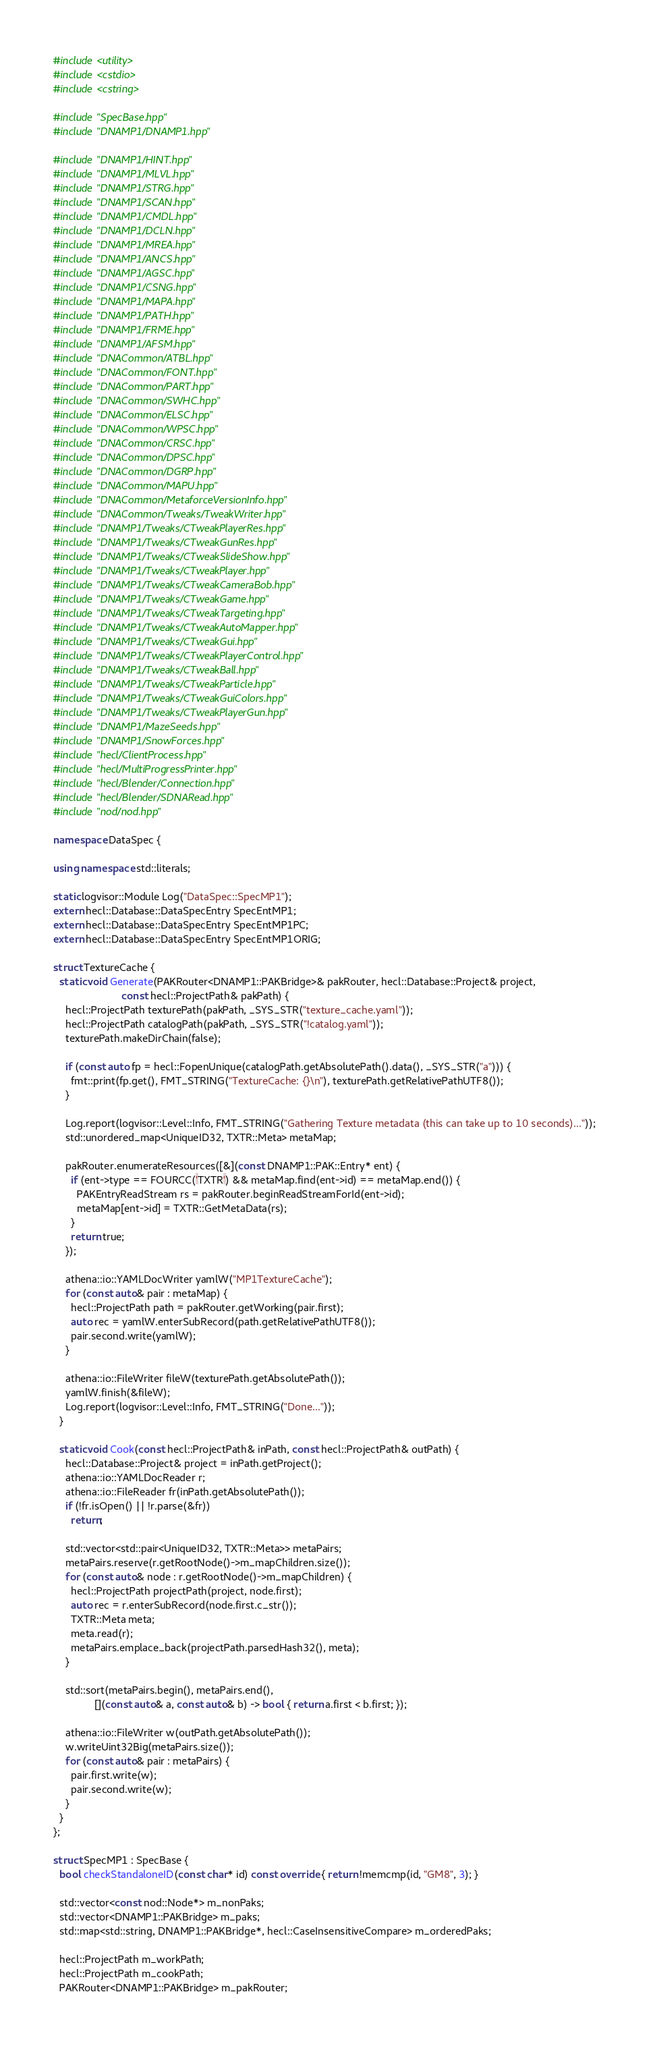Convert code to text. <code><loc_0><loc_0><loc_500><loc_500><_C++_>#include <utility>
#include <cstdio>
#include <cstring>

#include "SpecBase.hpp"
#include "DNAMP1/DNAMP1.hpp"

#include "DNAMP1/HINT.hpp"
#include "DNAMP1/MLVL.hpp"
#include "DNAMP1/STRG.hpp"
#include "DNAMP1/SCAN.hpp"
#include "DNAMP1/CMDL.hpp"
#include "DNAMP1/DCLN.hpp"
#include "DNAMP1/MREA.hpp"
#include "DNAMP1/ANCS.hpp"
#include "DNAMP1/AGSC.hpp"
#include "DNAMP1/CSNG.hpp"
#include "DNAMP1/MAPA.hpp"
#include "DNAMP1/PATH.hpp"
#include "DNAMP1/FRME.hpp"
#include "DNAMP1/AFSM.hpp"
#include "DNACommon/ATBL.hpp"
#include "DNACommon/FONT.hpp"
#include "DNACommon/PART.hpp"
#include "DNACommon/SWHC.hpp"
#include "DNACommon/ELSC.hpp"
#include "DNACommon/WPSC.hpp"
#include "DNACommon/CRSC.hpp"
#include "DNACommon/DPSC.hpp"
#include "DNACommon/DGRP.hpp"
#include "DNACommon/MAPU.hpp"
#include "DNACommon/MetaforceVersionInfo.hpp"
#include "DNACommon/Tweaks/TweakWriter.hpp"
#include "DNAMP1/Tweaks/CTweakPlayerRes.hpp"
#include "DNAMP1/Tweaks/CTweakGunRes.hpp"
#include "DNAMP1/Tweaks/CTweakSlideShow.hpp"
#include "DNAMP1/Tweaks/CTweakPlayer.hpp"
#include "DNAMP1/Tweaks/CTweakCameraBob.hpp"
#include "DNAMP1/Tweaks/CTweakGame.hpp"
#include "DNAMP1/Tweaks/CTweakTargeting.hpp"
#include "DNAMP1/Tweaks/CTweakAutoMapper.hpp"
#include "DNAMP1/Tweaks/CTweakGui.hpp"
#include "DNAMP1/Tweaks/CTweakPlayerControl.hpp"
#include "DNAMP1/Tweaks/CTweakBall.hpp"
#include "DNAMP1/Tweaks/CTweakParticle.hpp"
#include "DNAMP1/Tweaks/CTweakGuiColors.hpp"
#include "DNAMP1/Tweaks/CTweakPlayerGun.hpp"
#include "DNAMP1/MazeSeeds.hpp"
#include "DNAMP1/SnowForces.hpp"
#include "hecl/ClientProcess.hpp"
#include "hecl/MultiProgressPrinter.hpp"
#include "hecl/Blender/Connection.hpp"
#include "hecl/Blender/SDNARead.hpp"
#include "nod/nod.hpp"

namespace DataSpec {

using namespace std::literals;

static logvisor::Module Log("DataSpec::SpecMP1");
extern hecl::Database::DataSpecEntry SpecEntMP1;
extern hecl::Database::DataSpecEntry SpecEntMP1PC;
extern hecl::Database::DataSpecEntry SpecEntMP1ORIG;

struct TextureCache {
  static void Generate(PAKRouter<DNAMP1::PAKBridge>& pakRouter, hecl::Database::Project& project,
                       const hecl::ProjectPath& pakPath) {
    hecl::ProjectPath texturePath(pakPath, _SYS_STR("texture_cache.yaml"));
    hecl::ProjectPath catalogPath(pakPath, _SYS_STR("!catalog.yaml"));
    texturePath.makeDirChain(false);

    if (const auto fp = hecl::FopenUnique(catalogPath.getAbsolutePath().data(), _SYS_STR("a"))) {
      fmt::print(fp.get(), FMT_STRING("TextureCache: {}\n"), texturePath.getRelativePathUTF8());
    }

    Log.report(logvisor::Level::Info, FMT_STRING("Gathering Texture metadata (this can take up to 10 seconds)..."));
    std::unordered_map<UniqueID32, TXTR::Meta> metaMap;

    pakRouter.enumerateResources([&](const DNAMP1::PAK::Entry* ent) {
      if (ent->type == FOURCC('TXTR') && metaMap.find(ent->id) == metaMap.end()) {
        PAKEntryReadStream rs = pakRouter.beginReadStreamForId(ent->id);
        metaMap[ent->id] = TXTR::GetMetaData(rs);
      }
      return true;
    });

    athena::io::YAMLDocWriter yamlW("MP1TextureCache");
    for (const auto& pair : metaMap) {
      hecl::ProjectPath path = pakRouter.getWorking(pair.first);
      auto rec = yamlW.enterSubRecord(path.getRelativePathUTF8());
      pair.second.write(yamlW);
    }

    athena::io::FileWriter fileW(texturePath.getAbsolutePath());
    yamlW.finish(&fileW);
    Log.report(logvisor::Level::Info, FMT_STRING("Done..."));
  }

  static void Cook(const hecl::ProjectPath& inPath, const hecl::ProjectPath& outPath) {
    hecl::Database::Project& project = inPath.getProject();
    athena::io::YAMLDocReader r;
    athena::io::FileReader fr(inPath.getAbsolutePath());
    if (!fr.isOpen() || !r.parse(&fr))
      return;

    std::vector<std::pair<UniqueID32, TXTR::Meta>> metaPairs;
    metaPairs.reserve(r.getRootNode()->m_mapChildren.size());
    for (const auto& node : r.getRootNode()->m_mapChildren) {
      hecl::ProjectPath projectPath(project, node.first);
      auto rec = r.enterSubRecord(node.first.c_str());
      TXTR::Meta meta;
      meta.read(r);
      metaPairs.emplace_back(projectPath.parsedHash32(), meta);
    }

    std::sort(metaPairs.begin(), metaPairs.end(),
              [](const auto& a, const auto& b) -> bool { return a.first < b.first; });

    athena::io::FileWriter w(outPath.getAbsolutePath());
    w.writeUint32Big(metaPairs.size());
    for (const auto& pair : metaPairs) {
      pair.first.write(w);
      pair.second.write(w);
    }
  }
};

struct SpecMP1 : SpecBase {
  bool checkStandaloneID(const char* id) const override { return !memcmp(id, "GM8", 3); }

  std::vector<const nod::Node*> m_nonPaks;
  std::vector<DNAMP1::PAKBridge> m_paks;
  std::map<std::string, DNAMP1::PAKBridge*, hecl::CaseInsensitiveCompare> m_orderedPaks;

  hecl::ProjectPath m_workPath;
  hecl::ProjectPath m_cookPath;
  PAKRouter<DNAMP1::PAKBridge> m_pakRouter;
</code> 